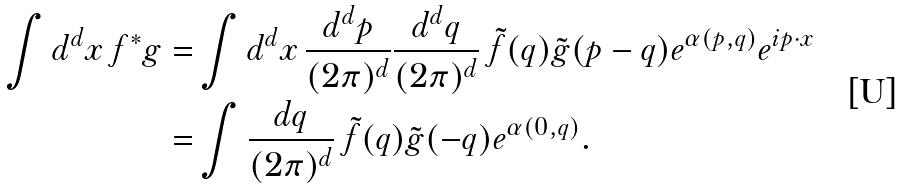Convert formula to latex. <formula><loc_0><loc_0><loc_500><loc_500>\int d ^ { d } x \, f ^ { * } g = & \int d ^ { d } x \, \frac { d ^ { d } p } { ( 2 \pi ) ^ { d } } \frac { d ^ { d } q } { ( 2 \pi ) ^ { d } } \, \tilde { f } ( q ) \tilde { g } ( p - q ) e ^ { \alpha ( p , q ) } e ^ { i p \cdot x } \\ = & \int \frac { d q } { ( 2 \pi ) ^ { d } } \, \tilde { f } ( q ) \tilde { g } ( - q ) e ^ { \alpha ( 0 , q ) } .</formula> 